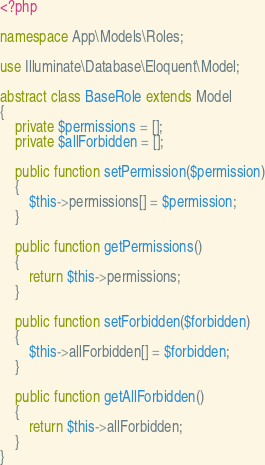Convert code to text. <code><loc_0><loc_0><loc_500><loc_500><_PHP_><?php

namespace App\Models\Roles;

use Illuminate\Database\Eloquent\Model;

abstract class BaseRole extends Model
{
    private $permissions = [];
    private $allForbidden = [];

    public function setPermission($permission)
    {
        $this->permissions[] = $permission;
    }

    public function getPermissions()
    {
        return $this->permissions;
    }

    public function setForbidden($forbidden)
    {
        $this->allForbidden[] = $forbidden;
    }

    public function getAllForbidden()
    {
        return $this->allForbidden;
    }
}
</code> 